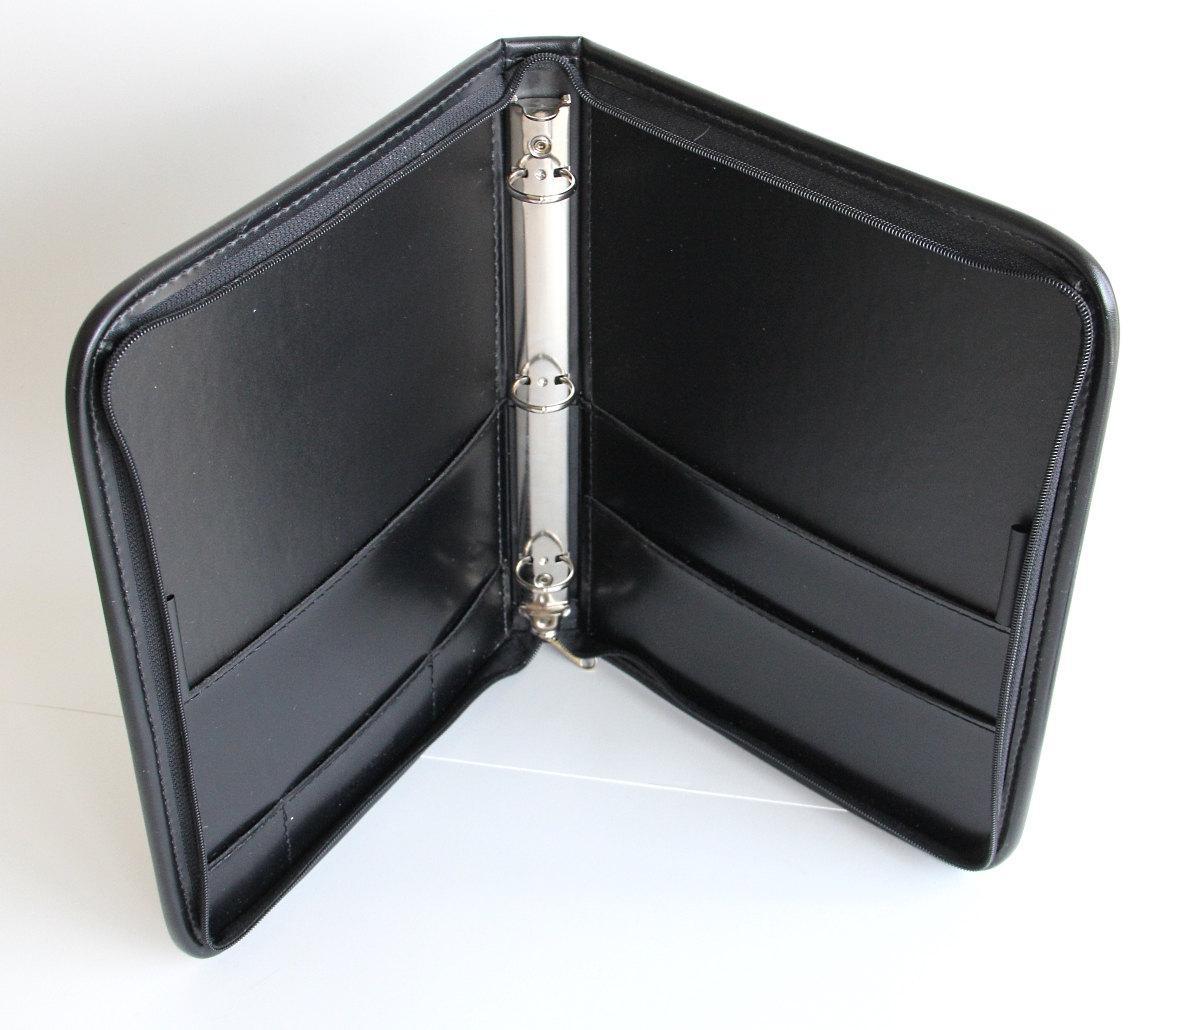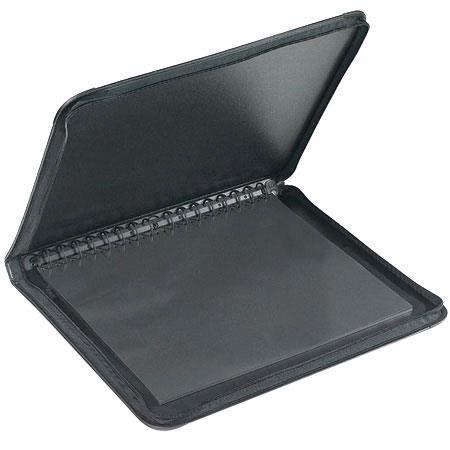The first image is the image on the left, the second image is the image on the right. For the images displayed, is the sentence "Two solid black notebook binders with center rings are in the open position." factually correct? Answer yes or no. Yes. The first image is the image on the left, the second image is the image on the right. Evaluate the accuracy of this statement regarding the images: "At least one image shows one closed black binder with a colored label on the front.". Is it true? Answer yes or no. No. 